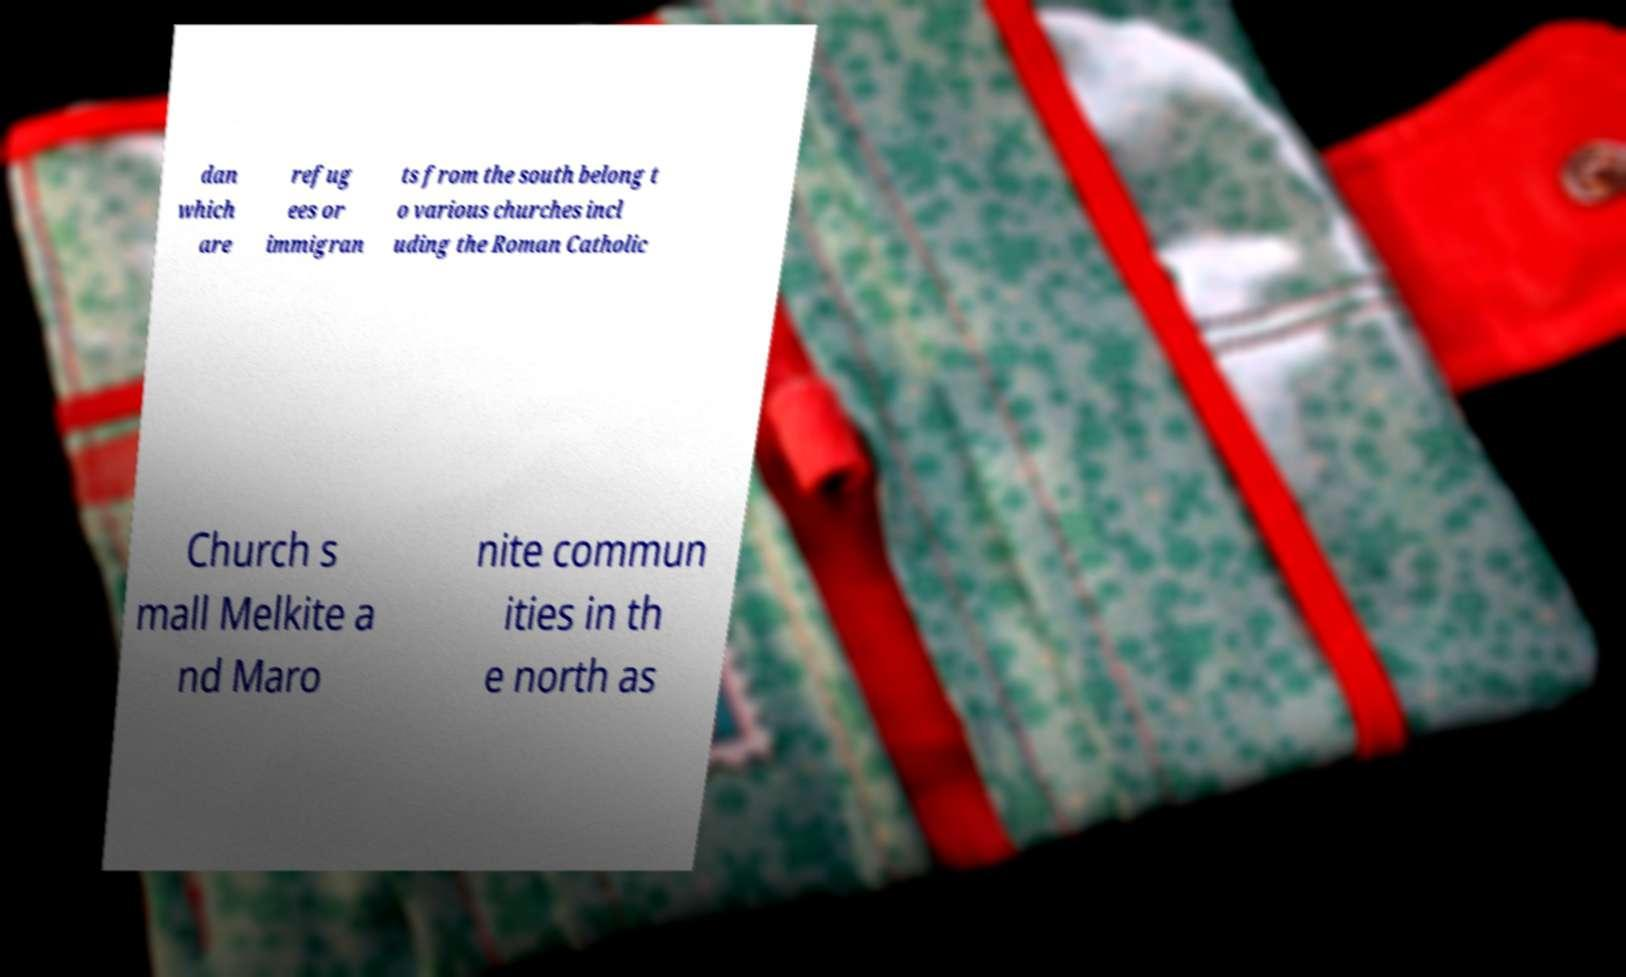Please identify and transcribe the text found in this image. dan which are refug ees or immigran ts from the south belong t o various churches incl uding the Roman Catholic Church s mall Melkite a nd Maro nite commun ities in th e north as 